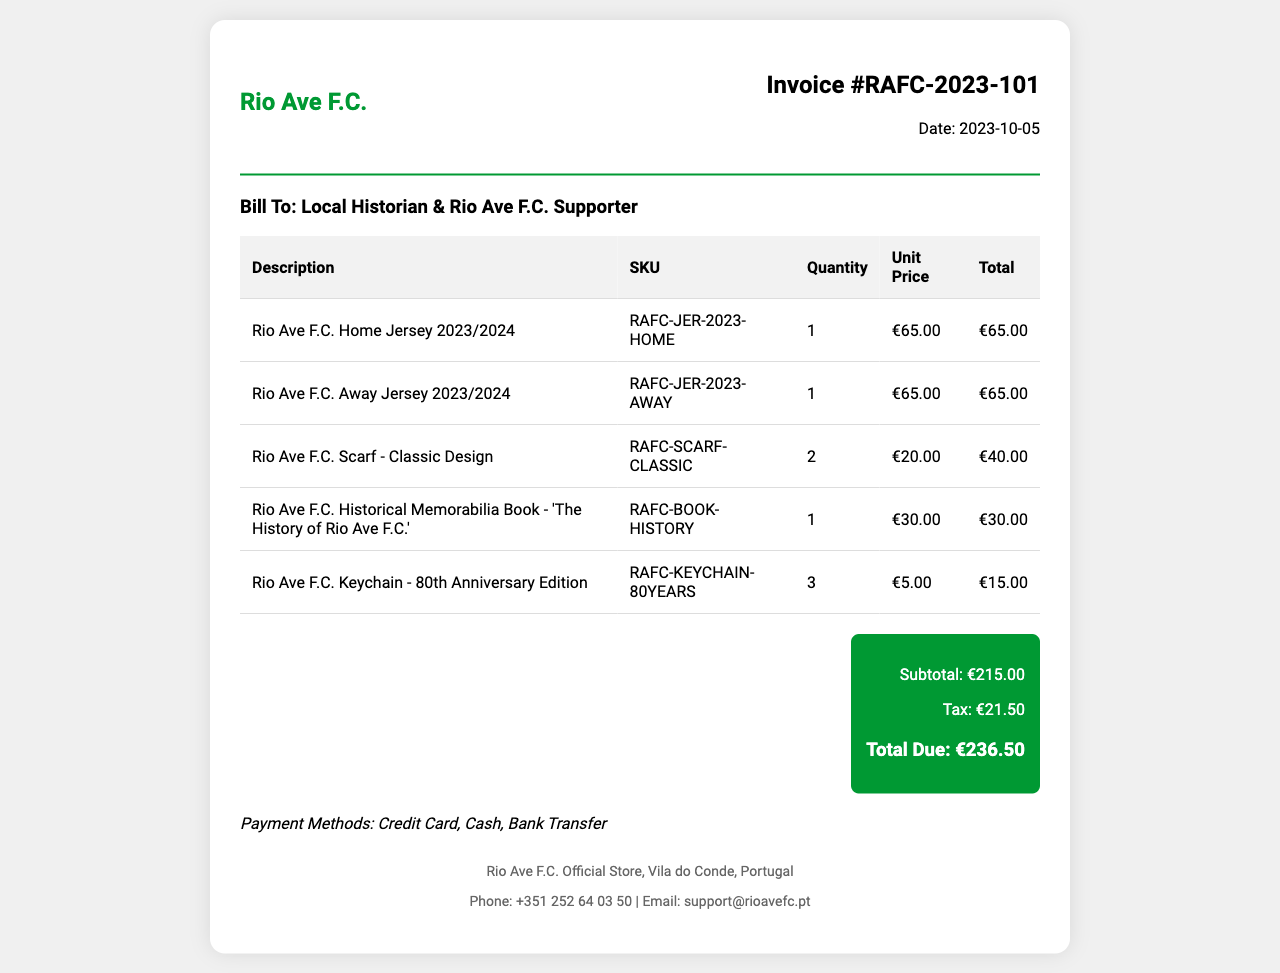What is the invoice number? The invoice number is specified at the top section of the document.
Answer: RAFC-2023-101 What date was the invoice issued? The date of the invoice is stated in the invoice details section.
Answer: 2023-10-05 How many 'Rio Ave F.C. Home Jerseys' were purchased? The quantity purchased for this item is indicated in the table under 'Quantity'.
Answer: 1 What is the total amount of tax? The tax total is listed in the total section at the bottom of the document.
Answer: €21.50 What is the total due amount? The total due is calculated from the subtotal and tax, found in the total section.
Answer: €236.50 What payment methods are indicated? Payment methods are provided in the payment methods section of the document.
Answer: Credit Card, Cash, Bank Transfer What is the unit price of the 'Rio Ave F.C. Scarf - Classic Design'? The unit price is detailed in the table under 'Unit Price' for this item.
Answer: €20.00 How many 'Rio Ave F.C. Keychains' were purchased? The quantity of keychains purchased is found in the table under 'Quantity'.
Answer: 3 What is the total cost for the 'Rio Ave F.C. Away Jersey 2023/2024'? The total cost can be found in the table under 'Total' for this item.
Answer: €65.00 